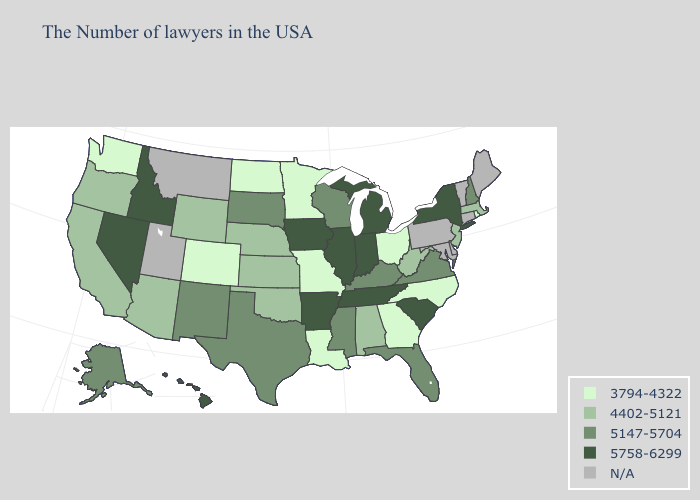What is the value of Oregon?
Be succinct. 4402-5121. What is the highest value in the USA?
Concise answer only. 5758-6299. Which states have the lowest value in the South?
Be succinct. North Carolina, Georgia, Louisiana. What is the lowest value in the Northeast?
Short answer required. 3794-4322. Among the states that border Indiana , does Michigan have the highest value?
Give a very brief answer. Yes. Is the legend a continuous bar?
Short answer required. No. Is the legend a continuous bar?
Concise answer only. No. What is the value of Tennessee?
Answer briefly. 5758-6299. Does Louisiana have the highest value in the South?
Concise answer only. No. Does the first symbol in the legend represent the smallest category?
Give a very brief answer. Yes. Name the states that have a value in the range 3794-4322?
Give a very brief answer. Rhode Island, North Carolina, Ohio, Georgia, Louisiana, Missouri, Minnesota, North Dakota, Colorado, Washington. What is the lowest value in states that border Massachusetts?
Concise answer only. 3794-4322. What is the value of Nebraska?
Answer briefly. 4402-5121. Name the states that have a value in the range 5147-5704?
Quick response, please. New Hampshire, Virginia, Florida, Kentucky, Wisconsin, Mississippi, Texas, South Dakota, New Mexico, Alaska. Does the first symbol in the legend represent the smallest category?
Keep it brief. Yes. 